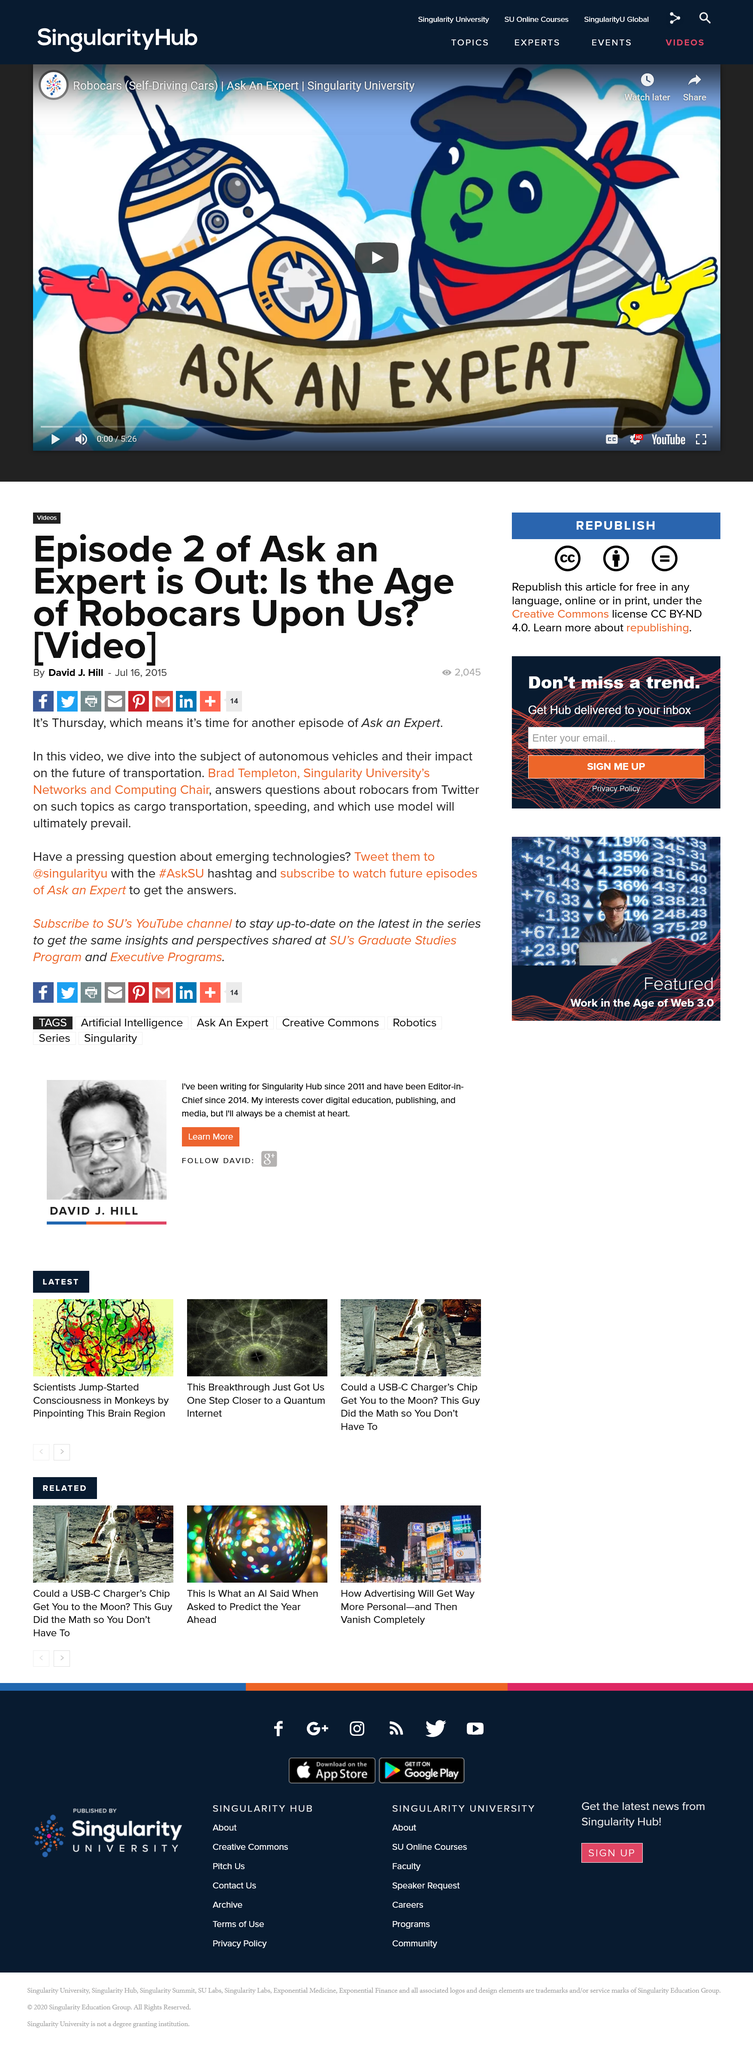Indicate a few pertinent items in this graphic. Singularity University's Networks and Computing department is headed by Brad Templeton, who is the chair of the department. In episode 2 of Ask an Expert, the subject is autonomous vehicles and their potential impact on the future. The Twitter handle for Singularity University is "@singularityu...". 